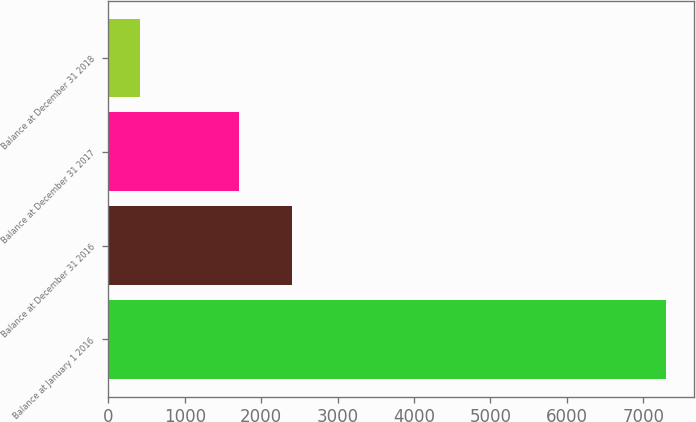Convert chart. <chart><loc_0><loc_0><loc_500><loc_500><bar_chart><fcel>Balance at January 1 2016<fcel>Balance at December 31 2016<fcel>Balance at December 31 2017<fcel>Balance at December 31 2018<nl><fcel>7298<fcel>2401.8<fcel>1713<fcel>410<nl></chart> 